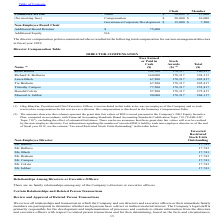According to Viavi Solutions's financial document, How much did Keith Barnes earn in cash? According to the financial document, 102,500. The relevant text states: "Keith Barnes 102,500 178,317 280,817..." Also, How much did Donald Colvin earn in cash? According to the financial document, 97,500. The relevant text states: "Donald Colvin 97,500 178,317 275,817..." Also, Why was Oleg Khaykin not included in the table? he was an employee of the Company and as such received no compensation for his services as a director.. The document states: "xecutive Officer, is not included in this table as he was an employee of the Company and as such received no compensation for his services as a direct..." Also, can you calculate: What is the difference between  Richard E. Belluzzo's total compensation as compared to Laura Black? Based on the calculation: (338,317-245,817), the result is 92500. This is based on the information: "Laura Black 67,500 178,317 245,817 Richard E. Belluzzo 160,000 178,317 338,317..." The key data points involved are: 245,817, 338,317. Also, can you calculate: What is the summed compensation for the top 3 most compensated directors? Based on the calculation: (338,317+280,817+275,817), the result is 894951. This is based on the information: "Keith Barnes 102,500 178,317 280,817 Richard E. Belluzzo 160,000 178,317 338,317 Donald Colvin 97,500 178,317 275,817..." The key data points involved are: 275,817, 280,817, 338,317. Also, can you calculate: What is the percentage difference of the total compensation between Timothy Campos and Tor Braham? To answer this question, I need to perform calculations using the financial data. The calculation is: (255,817-245,817)/245,817, which equals 4.07 (percentage). This is based on the information: "Laura Black 67,500 178,317 245,817 Timothy Campos 77,500 178,317 255,817..." The key data points involved are: 245,817, 255,817. 